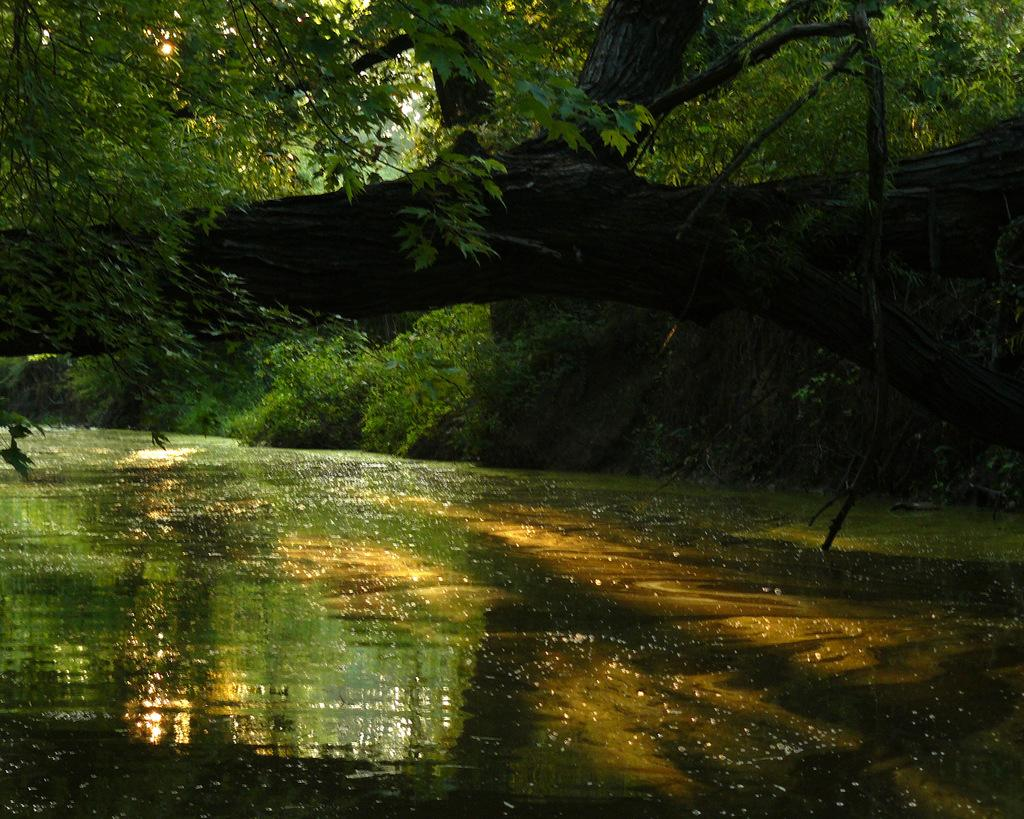Where was the image taken? The image is taken outdoors. What can be seen at the bottom of the image? There is a lake with water at the bottom of the image. What is located in the middle of the image? There is a branch of a tree in the middle of the image. What type of natural environment is visible in the image? There are many trees and plants in the image. Can you hear the cherries crying in the image? There are no cherries or crying sounds present in the image. 